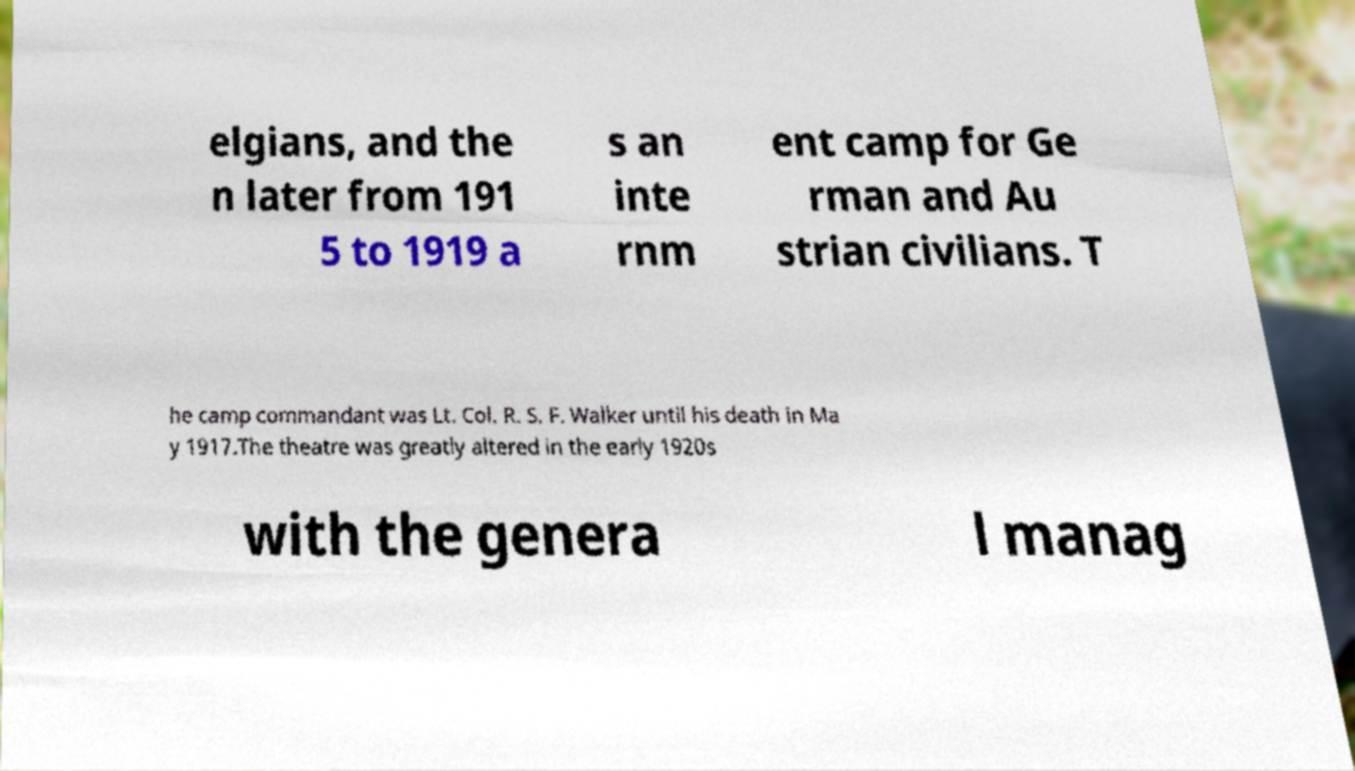For documentation purposes, I need the text within this image transcribed. Could you provide that? elgians, and the n later from 191 5 to 1919 a s an inte rnm ent camp for Ge rman and Au strian civilians. T he camp commandant was Lt. Col. R. S. F. Walker until his death in Ma y 1917.The theatre was greatly altered in the early 1920s with the genera l manag 